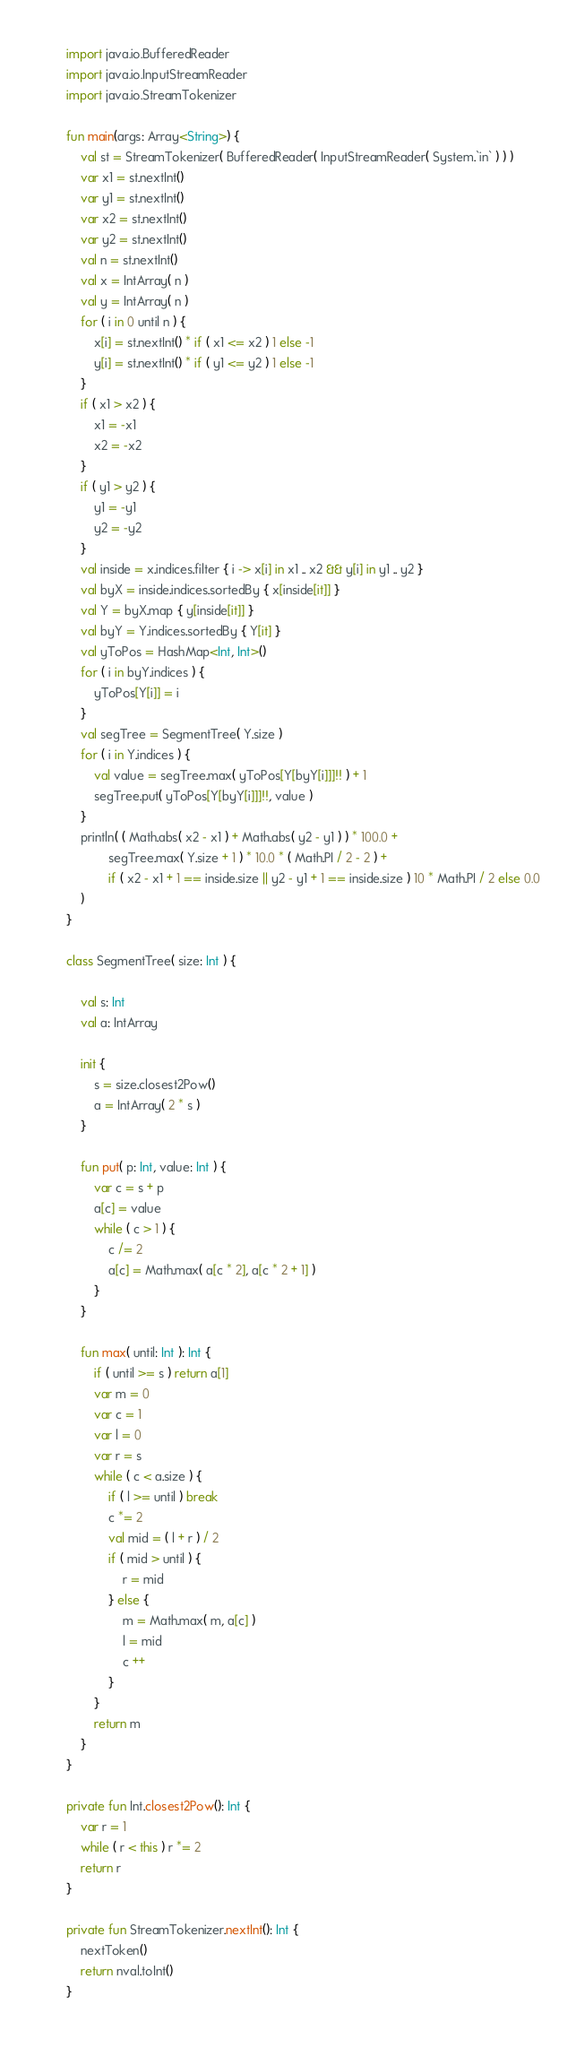<code> <loc_0><loc_0><loc_500><loc_500><_Kotlin_>import java.io.BufferedReader
import java.io.InputStreamReader
import java.io.StreamTokenizer

fun main(args: Array<String>) {
    val st = StreamTokenizer( BufferedReader( InputStreamReader( System.`in` ) ) )
    var x1 = st.nextInt()
    var y1 = st.nextInt()
    var x2 = st.nextInt()
    var y2 = st.nextInt()
    val n = st.nextInt()
    val x = IntArray( n )
    val y = IntArray( n )
    for ( i in 0 until n ) {
        x[i] = st.nextInt() * if ( x1 <= x2 ) 1 else -1
        y[i] = st.nextInt() * if ( y1 <= y2 ) 1 else -1
    }
    if ( x1 > x2 ) {
        x1 = -x1
        x2 = -x2
    }
    if ( y1 > y2 ) {
        y1 = -y1
        y2 = -y2
    }
    val inside = x.indices.filter { i -> x[i] in x1 .. x2 && y[i] in y1 .. y2 }
    val byX = inside.indices.sortedBy { x[inside[it]] }
    val Y = byX.map { y[inside[it]] }
    val byY = Y.indices.sortedBy { Y[it] }
    val yToPos = HashMap<Int, Int>()
    for ( i in byY.indices ) {
        yToPos[Y[i]] = i
    }
    val segTree = SegmentTree( Y.size )
    for ( i in Y.indices ) {
        val value = segTree.max( yToPos[Y[byY[i]]]!! ) + 1
        segTree.put( yToPos[Y[byY[i]]]!!, value )
    }
    println( ( Math.abs( x2 - x1 ) + Math.abs( y2 - y1 ) ) * 100.0 +
            segTree.max( Y.size + 1 ) * 10.0 * ( Math.PI / 2 - 2 ) +
            if ( x2 - x1 + 1 == inside.size || y2 - y1 + 1 == inside.size ) 10 * Math.PI / 2 else 0.0
    )
}

class SegmentTree( size: Int ) {

    val s: Int
    val a: IntArray

    init {
        s = size.closest2Pow()
        a = IntArray( 2 * s )
    }

    fun put( p: Int, value: Int ) {
        var c = s + p
        a[c] = value
        while ( c > 1 ) {
            c /= 2
            a[c] = Math.max( a[c * 2], a[c * 2 + 1] )
        }
    }

    fun max( until: Int ): Int {
        if ( until >= s ) return a[1]
        var m = 0
        var c = 1
        var l = 0
        var r = s
        while ( c < a.size ) {
            if ( l >= until ) break
            c *= 2
            val mid = ( l + r ) / 2
            if ( mid > until ) {
                r = mid
            } else {
                m = Math.max( m, a[c] )
                l = mid
                c ++
            }
        }
        return m
    }
}

private fun Int.closest2Pow(): Int {
    var r = 1
    while ( r < this ) r *= 2
    return r
}

private fun StreamTokenizer.nextInt(): Int {
    nextToken()
    return nval.toInt()
}
</code> 